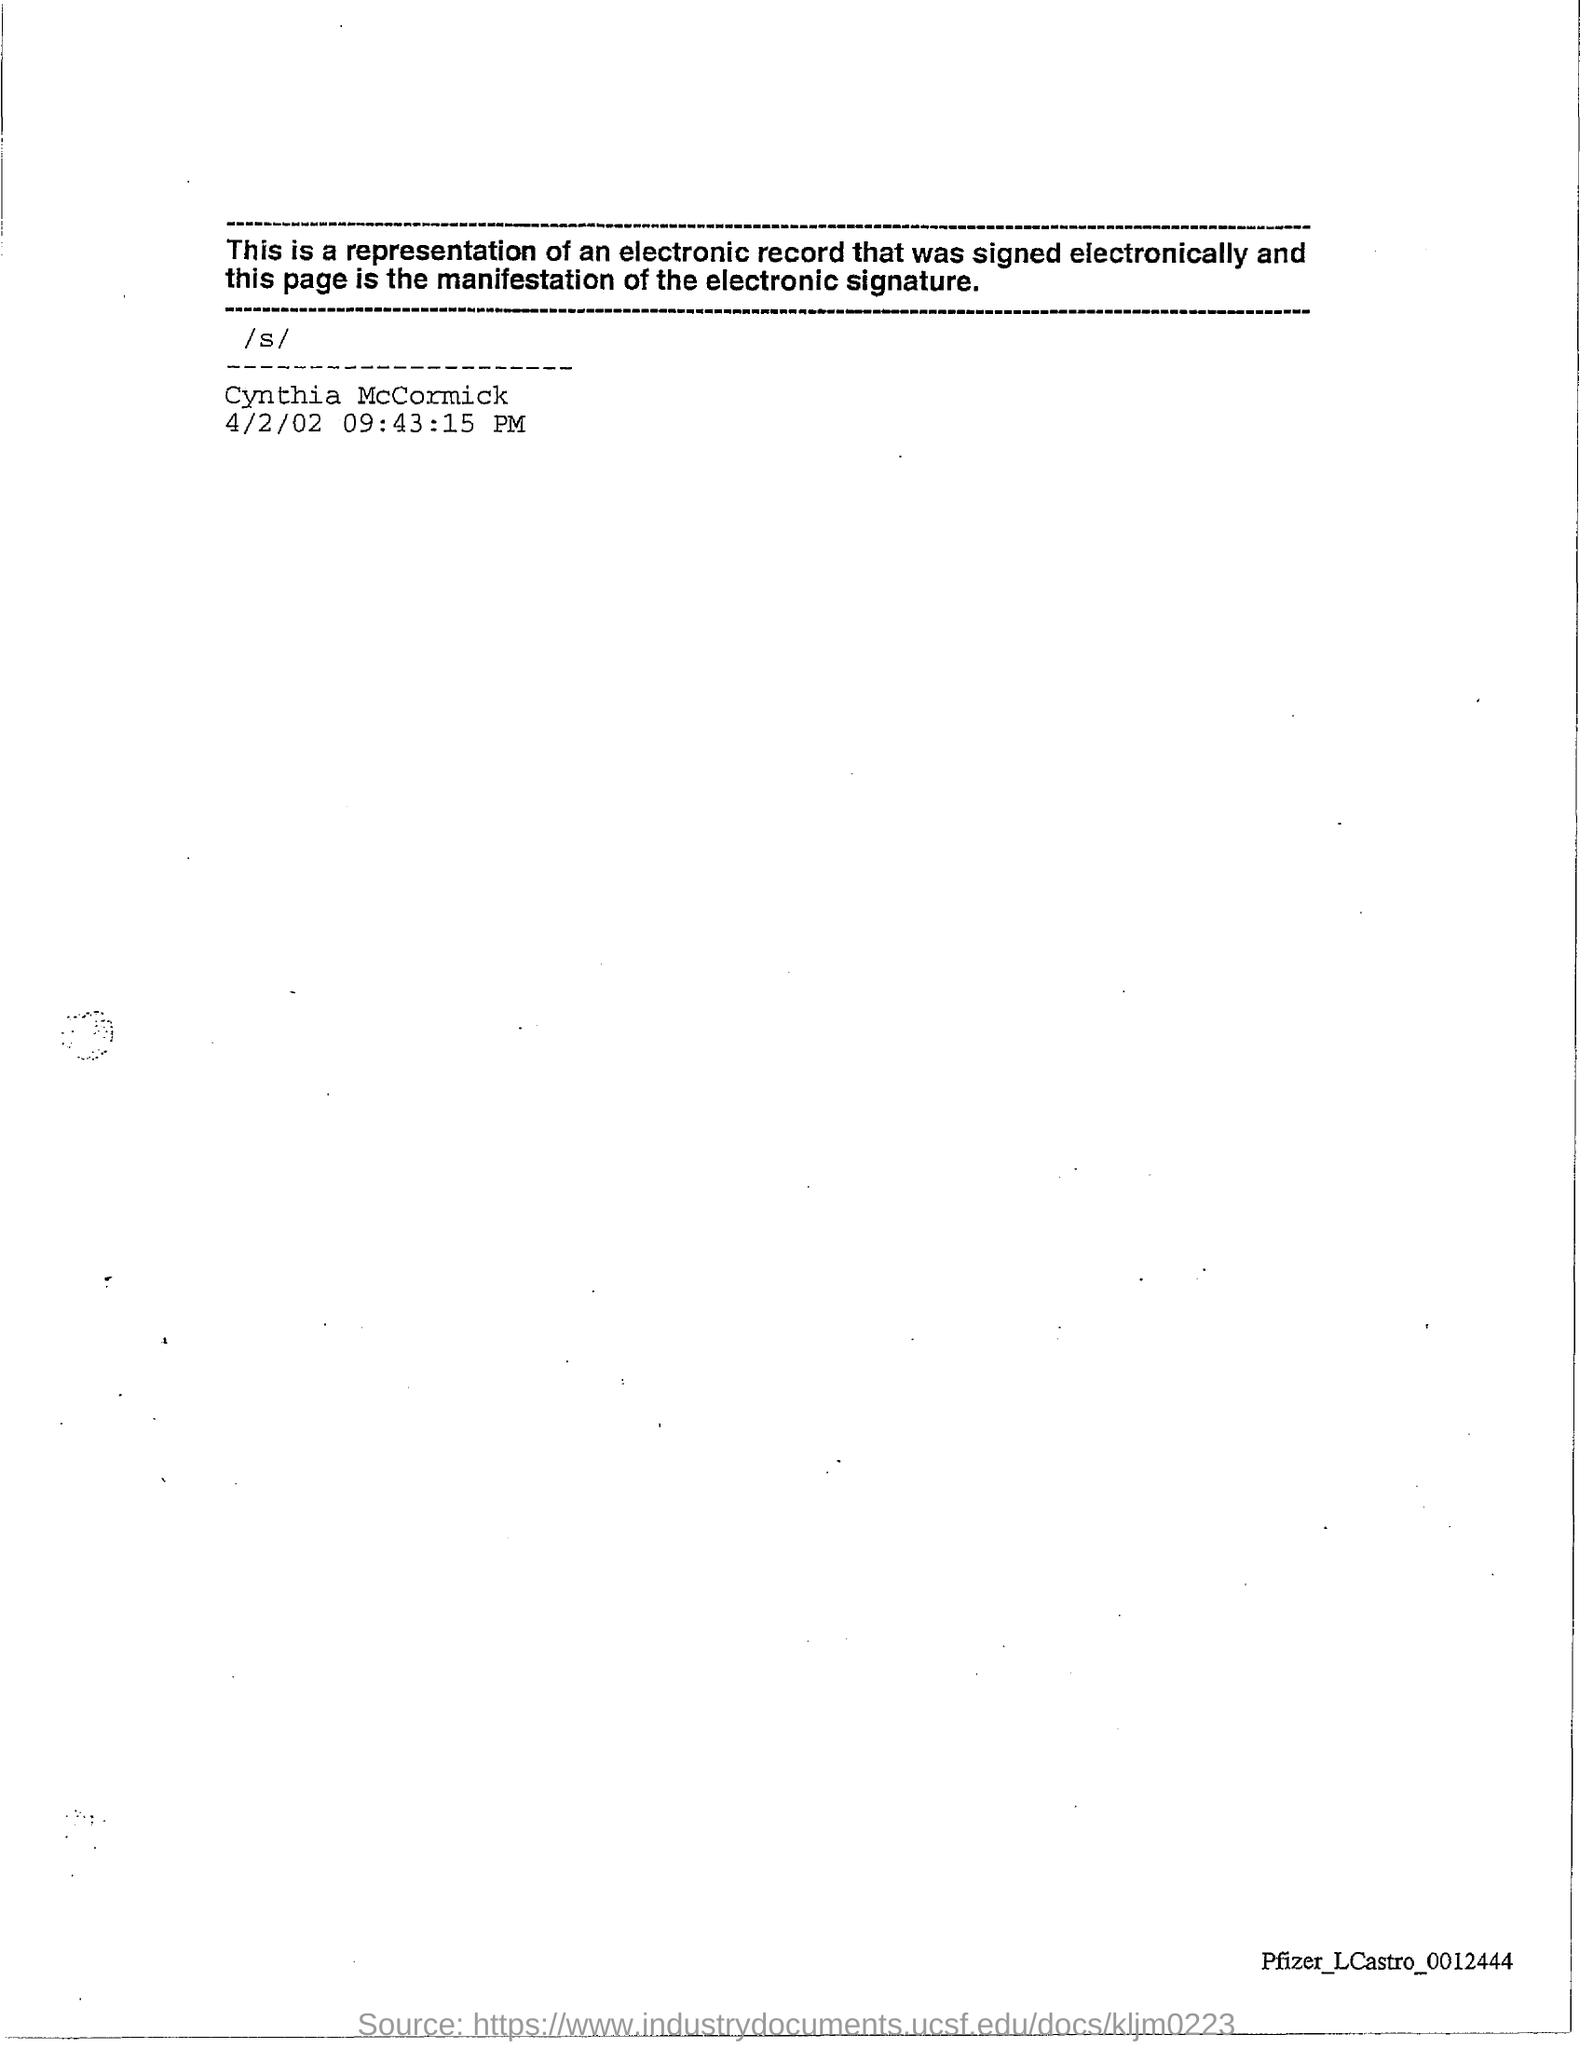What is the date mentioned?
Give a very brief answer. 4/2/02. 